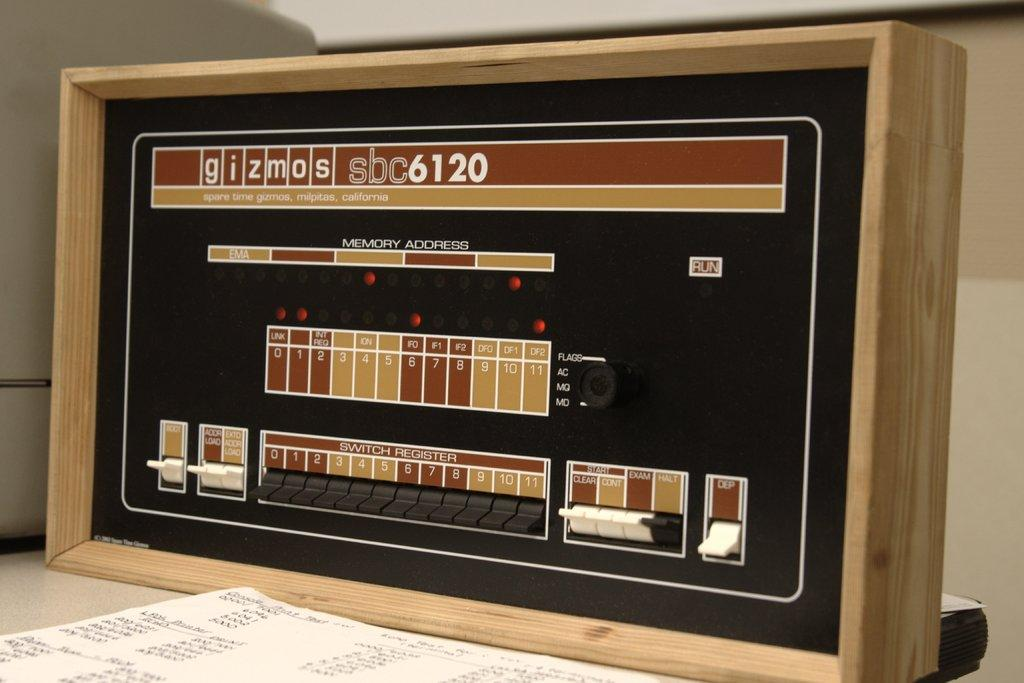<image>
Give a short and clear explanation of the subsequent image. A piece of machinery is labelled gizmos sbc6120. 